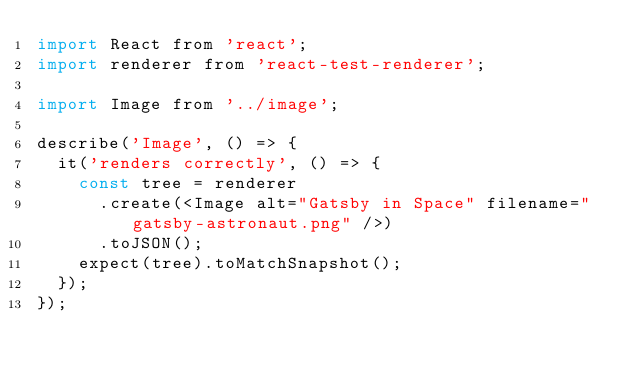Convert code to text. <code><loc_0><loc_0><loc_500><loc_500><_JavaScript_>import React from 'react';
import renderer from 'react-test-renderer';

import Image from '../image';

describe('Image', () => {
  it('renders correctly', () => {
    const tree = renderer
      .create(<Image alt="Gatsby in Space" filename="gatsby-astronaut.png" />)
      .toJSON();
    expect(tree).toMatchSnapshot();
  });
});
</code> 